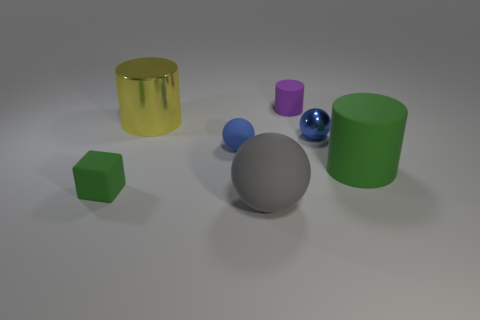Are there any small purple matte cylinders?
Your answer should be compact. Yes. Do the large metallic thing and the purple object have the same shape?
Make the answer very short. Yes. There is a matte cylinder left of the blue object to the right of the big matte ball; what number of green rubber things are on the right side of it?
Offer a very short reply. 1. The cylinder that is both behind the green rubber cylinder and right of the big shiny cylinder is made of what material?
Keep it short and to the point. Rubber. There is a object that is right of the purple object and in front of the tiny blue matte sphere; what is its color?
Your response must be concise. Green. Is there anything else that is the same color as the large matte ball?
Provide a succinct answer. No. The green matte thing that is left of the metal thing that is on the right side of the large yellow cylinder in front of the small cylinder is what shape?
Give a very brief answer. Cube. There is another small matte object that is the same shape as the gray rubber thing; what is its color?
Keep it short and to the point. Blue. What is the color of the object that is in front of the green matte cube left of the purple object?
Your answer should be very brief. Gray. There is a purple object that is the same shape as the yellow thing; what size is it?
Provide a short and direct response. Small. 